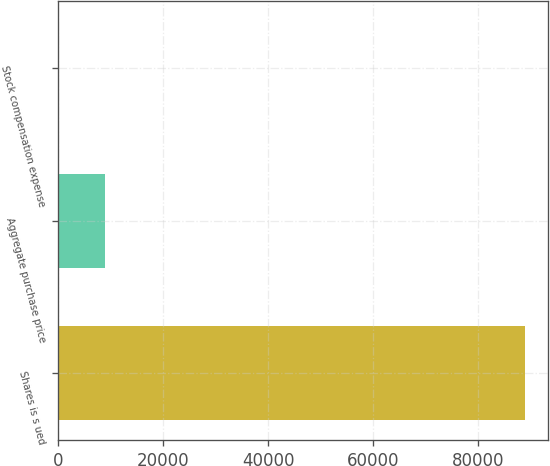Convert chart to OTSL. <chart><loc_0><loc_0><loc_500><loc_500><bar_chart><fcel>Shares is s ued<fcel>Aggregate purchase price<fcel>Stock compensation expense<nl><fcel>89000<fcel>8900.27<fcel>0.3<nl></chart> 